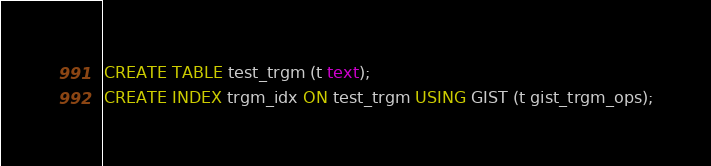Convert code to text. <code><loc_0><loc_0><loc_500><loc_500><_SQL_>CREATE TABLE test_trgm (t text);
CREATE INDEX trgm_idx ON test_trgm USING GIST (t gist_trgm_ops);
</code> 